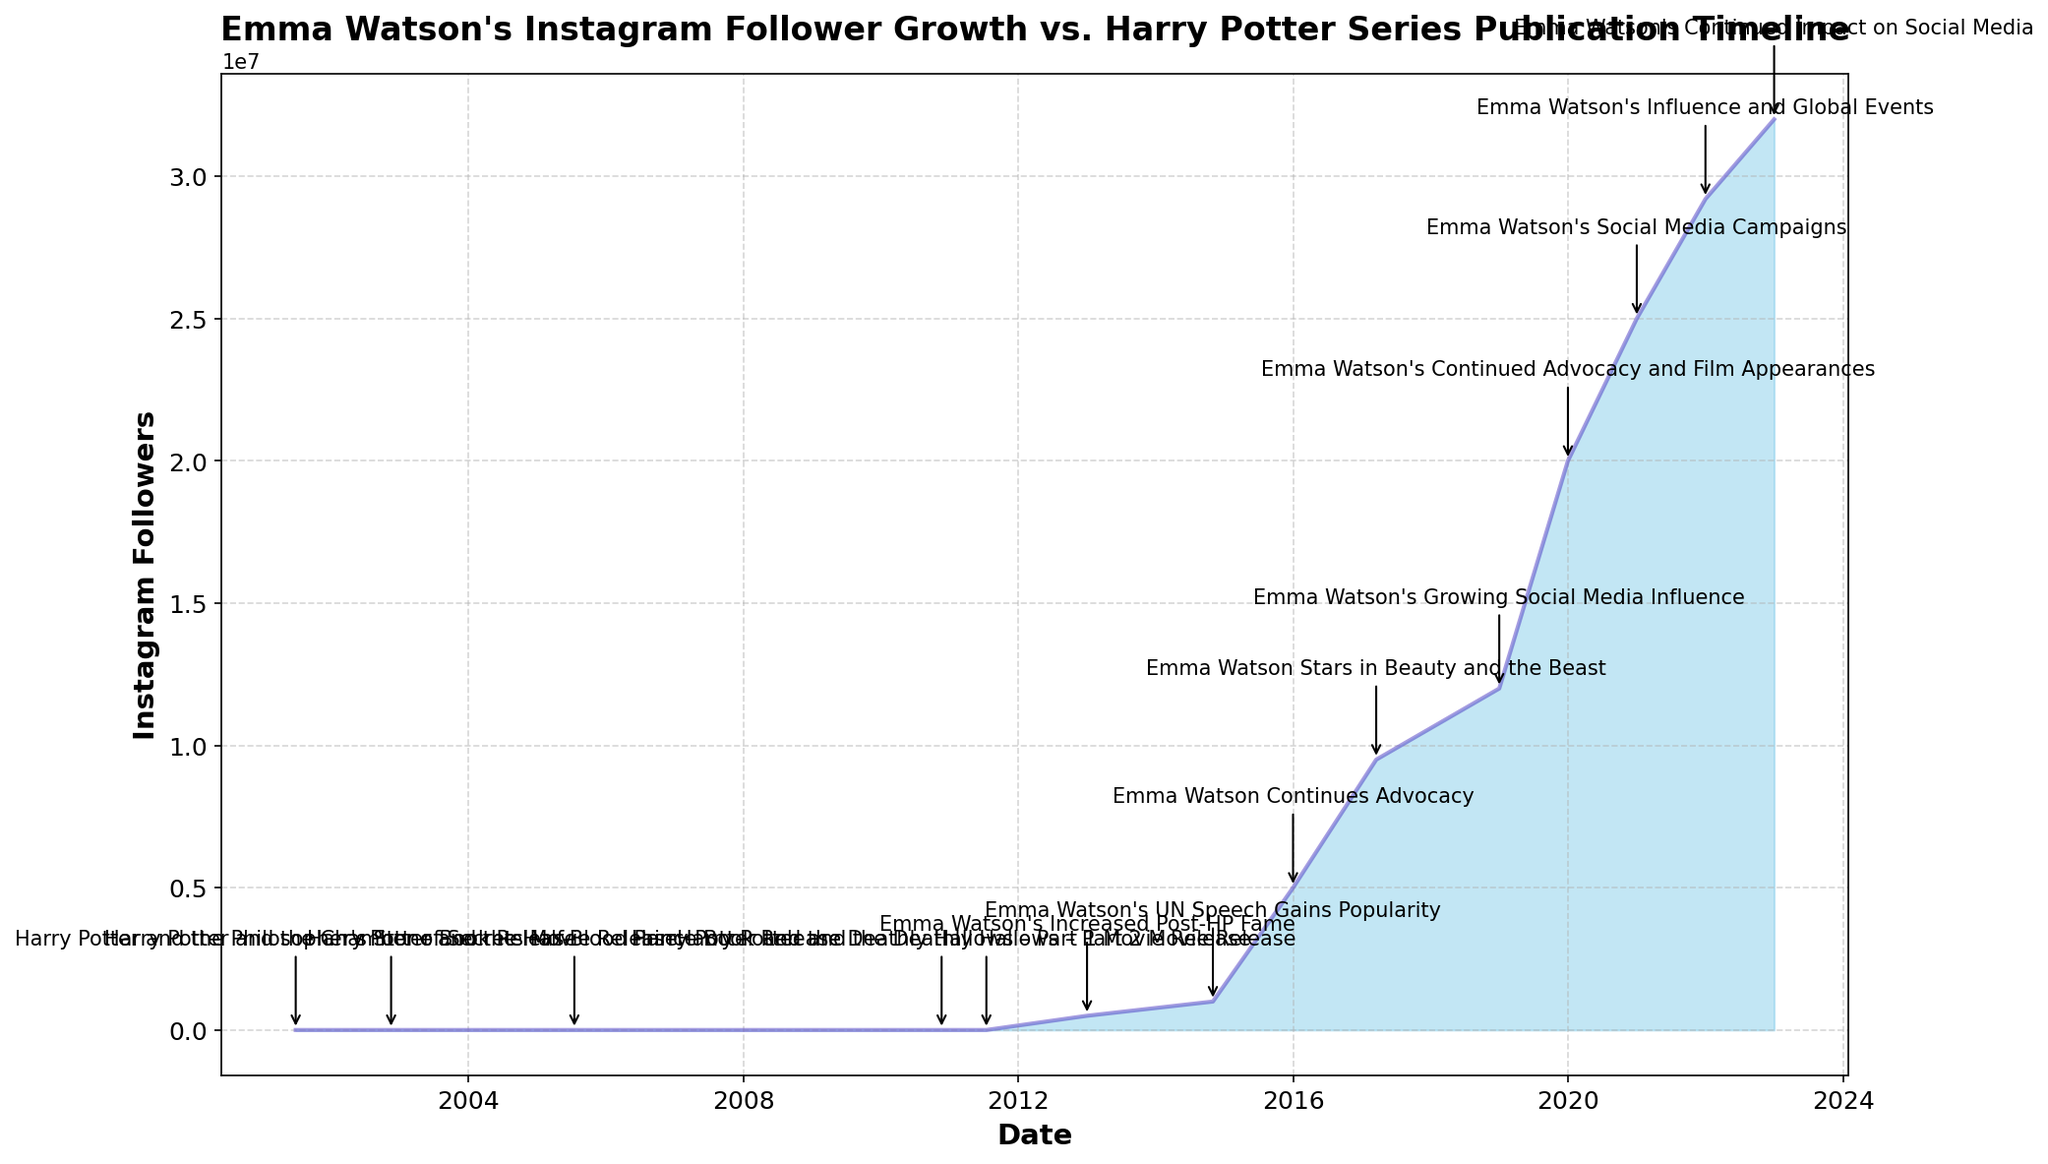What significant Harry Potter event occurred before Emma Watson started gaining followers on Instagram? The plot shows that significant Harry Potter events like book releases and movie releases had already occurred before Emma Watson's Instagram follower growth began around 2012.
Answer: Multiple Harry Potter book and movie releases, ending with Harry Potter and the Deathly Hallows – Part 2 Movie Release in 2011 When did Emma Watson's Instagram followers first exceed 1 million? The plot shows Emma Watson's Instagram followers reaching 1 million by the end of 2014, which coincides with her UN speech gaining popularity.
Answer: End of 2014 How many followers did Emma Watson gain between 2017 and 2020? According to the plot, Emma Watson's followers in 2017 were around 9,500,000 and increased to 25,000,000 by the end of 2020. Subtracting the initial value from the final value gives us the gain: 25,000,000 - 9,500,000.
Answer: 15,500,000 Which year did Emma Watson experience a significant surge in Instagram followers after her involvement in a major film, and what was the title of the film? The plotted data shows a sharp increase in followers around 2017, which correlates with Emma Watson starring in "Beauty and the Beast."
Answer: 2017, Beauty and the Beast Comparing the years 2015 and 2019, in which year did Emma Watson's followers increase more rapidly? The plot shows a steep rise in followers for both years. In 2019, followers increased from 12,000,000 (end of 2018) to 20,000,000, a gain of 8,000,000. In 2015, they increased from 1,000,000 (end of 2014) to 5,000,000, a gain of 4,000,000.
Answer: 2019 What is the approximate duration between the last Harry Potter event and Emma Watson hitting 5 million Instagram followers? The last Harry Potter event in the chart is the 2011 movie release, and Emma Watson's followers hit 5 million by the end of 2015. The duration between these two points is from late 2011 to the end of 2015.
Answer: Approximately 4 years How did the follower growth from 2021 to 2022 compare with the growth from 2019 to 2020? From 2021 to 2022, Emma Watson's followers increased from 29,200,000 to 32,000,000, an increase of 2,800,000. From 2019 to 2020, the followers increased from 20,000,000 to 25,000,000, an increase of 5,000,000.
Answer: 2019 to 2020 growth was higher What visual feature indicates the Harry Potter events on the plot, and how do they stand out compared to other annotations? The plot uses arrow annotations to mark the Harry Potter events, directing from the event year to an annotated point above the follower growth line, making them stand out.
Answer: Arrow annotations During what period did Emma Watson’s Instagram followers increase the most steadily without any notable spikes observed? Between 2018 and 2019, the plot shows a consistent upward trend of steady growth without any sharp spikes.
Answer: 2018 to 2019 